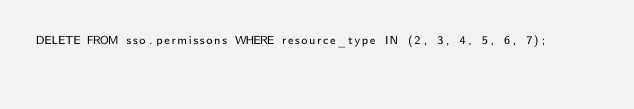<code> <loc_0><loc_0><loc_500><loc_500><_SQL_>DELETE FROM sso.permissons WHERE resource_type IN (2, 3, 4, 5, 6, 7);</code> 